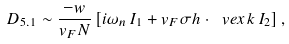Convert formula to latex. <formula><loc_0><loc_0><loc_500><loc_500>D _ { 5 . 1 } \sim \frac { - w } { v _ { F } N } \left [ i \omega _ { n } \, I _ { 1 } + v _ { F } \sigma h \cdot \ v e x { k } \, I _ { 2 } \right ] ,</formula> 